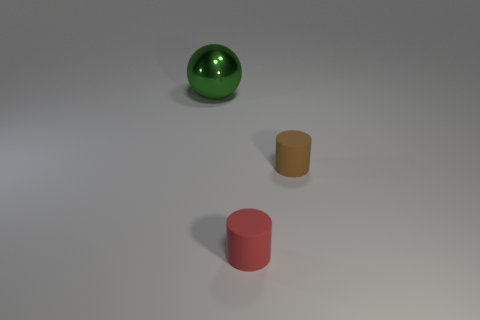Subtract all gray balls. Subtract all gray blocks. How many balls are left? 1 Add 3 brown shiny objects. How many objects exist? 6 Subtract all cylinders. How many objects are left? 1 Add 3 big green metal balls. How many big green metal balls exist? 4 Subtract 0 red spheres. How many objects are left? 3 Subtract all rubber things. Subtract all gray rubber balls. How many objects are left? 1 Add 3 tiny red rubber cylinders. How many tiny red rubber cylinders are left? 4 